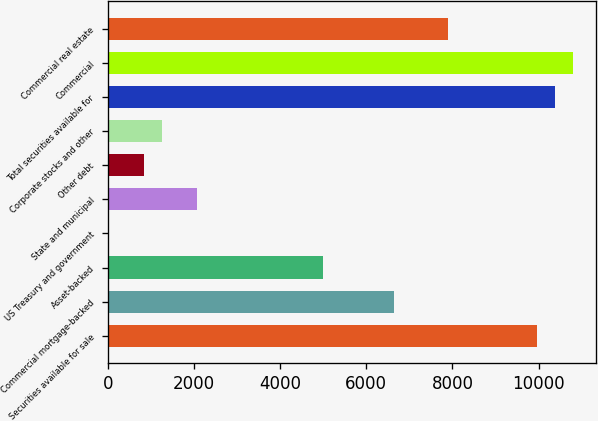<chart> <loc_0><loc_0><loc_500><loc_500><bar_chart><fcel>Securities available for sale<fcel>Commercial mortgage-backed<fcel>Asset-backed<fcel>US Treasury and government<fcel>State and municipal<fcel>Other debt<fcel>Corporate stocks and other<fcel>Total securities available for<fcel>Commercial<fcel>Commercial real estate<nl><fcel>9970.2<fcel>6647.8<fcel>4986.6<fcel>3<fcel>2079.5<fcel>833.6<fcel>1248.9<fcel>10385.5<fcel>10800.8<fcel>7893.7<nl></chart> 